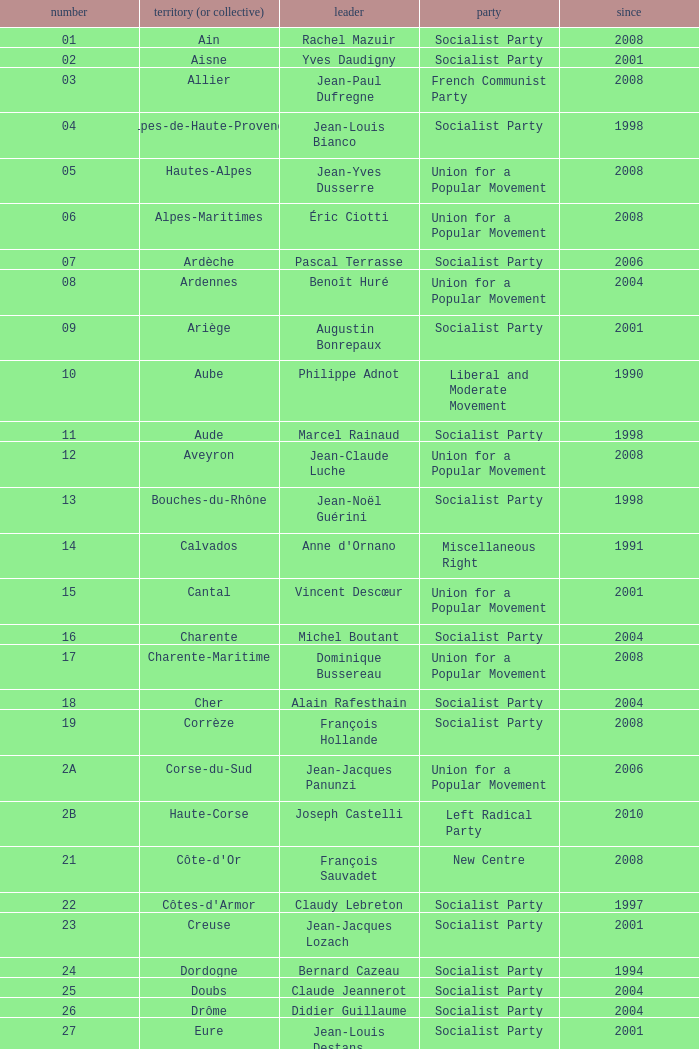Which department has Guy-Dominique Kennel as president since 2008? Bas-Rhin. Would you be able to parse every entry in this table? {'header': ['number', 'territory (or collective)', 'leader', 'party', 'since'], 'rows': [['01', 'Ain', 'Rachel Mazuir', 'Socialist Party', '2008'], ['02', 'Aisne', 'Yves Daudigny', 'Socialist Party', '2001'], ['03', 'Allier', 'Jean-Paul Dufregne', 'French Communist Party', '2008'], ['04', 'Alpes-de-Haute-Provence', 'Jean-Louis Bianco', 'Socialist Party', '1998'], ['05', 'Hautes-Alpes', 'Jean-Yves Dusserre', 'Union for a Popular Movement', '2008'], ['06', 'Alpes-Maritimes', 'Éric Ciotti', 'Union for a Popular Movement', '2008'], ['07', 'Ardèche', 'Pascal Terrasse', 'Socialist Party', '2006'], ['08', 'Ardennes', 'Benoît Huré', 'Union for a Popular Movement', '2004'], ['09', 'Ariège', 'Augustin Bonrepaux', 'Socialist Party', '2001'], ['10', 'Aube', 'Philippe Adnot', 'Liberal and Moderate Movement', '1990'], ['11', 'Aude', 'Marcel Rainaud', 'Socialist Party', '1998'], ['12', 'Aveyron', 'Jean-Claude Luche', 'Union for a Popular Movement', '2008'], ['13', 'Bouches-du-Rhône', 'Jean-Noël Guérini', 'Socialist Party', '1998'], ['14', 'Calvados', "Anne d'Ornano", 'Miscellaneous Right', '1991'], ['15', 'Cantal', 'Vincent Descœur', 'Union for a Popular Movement', '2001'], ['16', 'Charente', 'Michel Boutant', 'Socialist Party', '2004'], ['17', 'Charente-Maritime', 'Dominique Bussereau', 'Union for a Popular Movement', '2008'], ['18', 'Cher', 'Alain Rafesthain', 'Socialist Party', '2004'], ['19', 'Corrèze', 'François Hollande', 'Socialist Party', '2008'], ['2A', 'Corse-du-Sud', 'Jean-Jacques Panunzi', 'Union for a Popular Movement', '2006'], ['2B', 'Haute-Corse', 'Joseph Castelli', 'Left Radical Party', '2010'], ['21', "Côte-d'Or", 'François Sauvadet', 'New Centre', '2008'], ['22', "Côtes-d'Armor", 'Claudy Lebreton', 'Socialist Party', '1997'], ['23', 'Creuse', 'Jean-Jacques Lozach', 'Socialist Party', '2001'], ['24', 'Dordogne', 'Bernard Cazeau', 'Socialist Party', '1994'], ['25', 'Doubs', 'Claude Jeannerot', 'Socialist Party', '2004'], ['26', 'Drôme', 'Didier Guillaume', 'Socialist Party', '2004'], ['27', 'Eure', 'Jean-Louis Destans', 'Socialist Party', '2001'], ['28', 'Eure-et-Loir', 'Albéric de Montgolfier', 'Union for a Popular Movement', '2001'], ['29', 'Finistère', 'Pierre Maille', 'Socialist Party', '1998'], ['30', 'Gard', 'Damien Alary', 'Socialist Party', '2001'], ['31', 'Haute-Garonne', 'Pierre Izard', 'Socialist Party', '1988'], ['32', 'Gers', 'Philippe Martin', 'Socialist Party', '1998'], ['33', 'Gironde', 'Philippe Madrelle', 'Socialist Party', '1988'], ['34', 'Hérault', 'André Vezinhet', 'Socialist Party', '1998'], ['35', 'Ille-et-Vilaine', 'Jean-Louis Tourenne', 'Socialist Party', '2004'], ['36', 'Indre', 'Louis Pinton', 'Union for a Popular Movement', '1998'], ['37', 'Indre-et-Loire', 'Claude Roiron', 'Socialist Party', '2008'], ['38', 'Isère', 'André Vallini', 'Socialist Party', '2001'], ['39', 'Jura', 'Jean Raquin', 'Miscellaneous Right', '2008'], ['40', 'Landes', 'Henri Emmanuelli', 'Socialist Party', '1982'], ['41', 'Loir-et-Cher', 'Maurice Leroy', 'New Centre', '2004'], ['42', 'Loire', 'Bernard Bonne', 'Union for a Popular Movement', '2008'], ['43', 'Haute-Loire', 'Gérard Roche', 'Union for a Popular Movement', '2004'], ['44', 'Loire-Atlantique', 'Patrick Mareschal', 'Socialist Party', '2004'], ['45', 'Loiret', 'Éric Doligé', 'Union for a Popular Movement', '1994'], ['46', 'Lot', 'Gérard Miquel', 'Socialist Party', '2004'], ['47', 'Lot-et-Garonne', 'Pierre Camani', 'Socialist Party', '2008'], ['48', 'Lozère', 'Jean-Paul Pourquier', 'Union for a Popular Movement', '2004'], ['49', 'Maine-et-Loire', 'Christophe Béchu', 'Union for a Popular Movement', '2004'], ['50', 'Manche', 'Jean-François Le Grand', 'Union for a Popular Movement', '1998'], ['51', 'Marne', 'René-Paul Savary', 'Union for a Popular Movement', '2003'], ['52', 'Haute-Marne', 'Bruno Sido', 'Union for a Popular Movement', '1998'], ['53', 'Mayenne', 'Jean Arthuis', 'Miscellaneous Centre', '1992'], ['54', 'Meurthe-et-Moselle', 'Michel Dinet', 'Socialist Party', '1998'], ['55', 'Meuse', 'Christian Namy', 'Miscellaneous Right', '2004'], ['56', 'Morbihan', 'Joseph-François Kerguéris', 'Democratic Movement', '2004'], ['57', 'Moselle', 'Philippe Leroy', 'Union for a Popular Movement', '1992'], ['58', 'Nièvre', 'Marcel Charmant', 'Socialist Party', '2001'], ['59', 'Nord', 'Patrick Kanner', 'Socialist Party', '1998'], ['60', 'Oise', 'Yves Rome', 'Socialist Party', '2004'], ['61', 'Orne', 'Alain Lambert', 'Union for a Popular Movement', '2007'], ['62', 'Pas-de-Calais', 'Dominique Dupilet', 'Socialist Party', '2004'], ['63', 'Puy-de-Dôme', 'Jean-Yves Gouttebel', 'Socialist Party', '2004'], ['64', 'Pyrénées-Atlantiques', 'Jean Castaings', 'Union for a Popular Movement', '2008'], ['65', 'Hautes-Pyrénées', 'Josette Durrieu', 'Socialist Party', '2008'], ['66', 'Pyrénées-Orientales', 'Christian Bourquin', 'Socialist Party', '1998'], ['67', 'Bas-Rhin', 'Guy-Dominique Kennel', 'Union for a Popular Movement', '2008'], ['68', 'Haut-Rhin', 'Charles Buttner', 'Union for a Popular Movement', '2004'], ['69', 'Rhône', 'Michel Mercier', 'Miscellaneous Centre', '1990'], ['70', 'Haute-Saône', 'Yves Krattinger', 'Socialist Party', '2002'], ['71', 'Saône-et-Loire', 'Arnaud Montebourg', 'Socialist Party', '2008'], ['72', 'Sarthe', 'Roland du Luart', 'Union for a Popular Movement', '1998'], ['73', 'Savoie', 'Hervé Gaymard', 'Union for a Popular Movement', '2008'], ['74', 'Haute-Savoie', 'Christian Monteil', 'Miscellaneous Right', '2008'], ['75', 'Paris', 'Bertrand Delanoë', 'Socialist Party', '2001'], ['76', 'Seine-Maritime', 'Didier Marie', 'Socialist Party', '2004'], ['77', 'Seine-et-Marne', 'Vincent Eblé', 'Socialist Party', '2004'], ['78', 'Yvelines', 'Pierre Bédier', 'Union for a Popular Movement', '2005'], ['79', 'Deux-Sèvres', 'Éric Gautier', 'Socialist Party', '2008'], ['80', 'Somme', 'Christian Manable', 'Socialist Party', '2008'], ['81', 'Tarn', 'Thierry Carcenac', 'Socialist Party', '1991'], ['82', 'Tarn-et-Garonne', 'Jean-Michel Baylet', 'Left Radical Party', '1986'], ['83', 'Var', 'Horace Lanfranchi', 'Union for a Popular Movement', '2002'], ['84', 'Vaucluse', 'Claude Haut', 'Socialist Party', '2001'], ['85', 'Vendée', 'Philippe de Villiers', 'Movement for France', '1988'], ['86', 'Vienne', 'Claude Bertaud', 'Union for a Popular Movement', '2008'], ['87', 'Haute-Vienne', 'Marie-Françoise Pérol-Dumont', 'Socialist Party', '2004'], ['88', 'Vosges', 'Christian Poncelet', 'Union for a Popular Movement', '1976'], ['89', 'Yonne', 'Jean-Marie Rolland', 'Union for a Popular Movement', '2008'], ['90', 'Territoire de Belfort', 'Yves Ackermann', 'Socialist Party', '2004'], ['91', 'Essonne', 'Michel Berson', 'Socialist Party', '1998'], ['92', 'Hauts-de-Seine', 'Patrick Devedjian', 'Union for a Popular Movement', '2007'], ['93', 'Seine-Saint-Denis', 'Claude Bartolone', 'Socialist Party', '2008'], ['94', 'Val-de-Marne', 'Christian Favier', 'French Communist Party', '2001'], ['95', 'Val-d’Oise', 'Arnaud Bazin', 'Union for a Popular Movement', '2011'], ['971', 'Guadeloupe', 'Jacques Gillot', 'United Guadeloupe, Socialism and Realities', '2001'], ['972', 'Martinique', 'Claude Lise', 'Martinican Democratic Rally', '1992'], ['973', 'Guyane', 'Alain Tien-Liong', 'Miscellaneous Left', '2008'], ['974', 'Réunion', 'Nassimah Dindar', 'Union for a Popular Movement', '2004'], ['975', 'Saint-Pierre-et-Miquelon (overseas collect.)', 'Stéphane Artano', 'Archipelago Tomorrow', '2006'], ['976', 'Mayotte (overseas collect.)', 'Ahmed Attoumani Douchina', 'Union for a Popular Movement', '2008']]} 